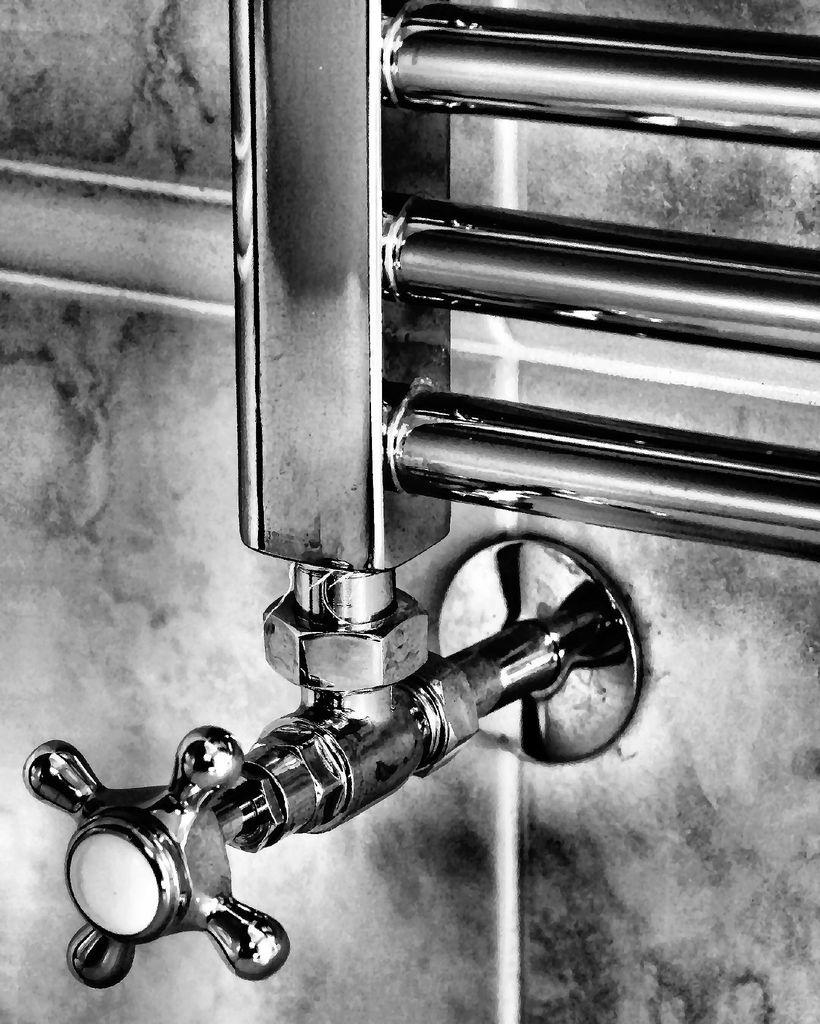What is the main object in the image? There is a tap in the image. What else can be seen related to the tap? There are pipes in the image. What type of structure is visible in the image? There is a wall visible in the image. How is the image presented? The image is in black and white mode. Where is the jewel placed in the image? There is no jewel present in the image. What type of branch can be seen growing from the tap in the image? There is no branch growing from the tap in the image. 